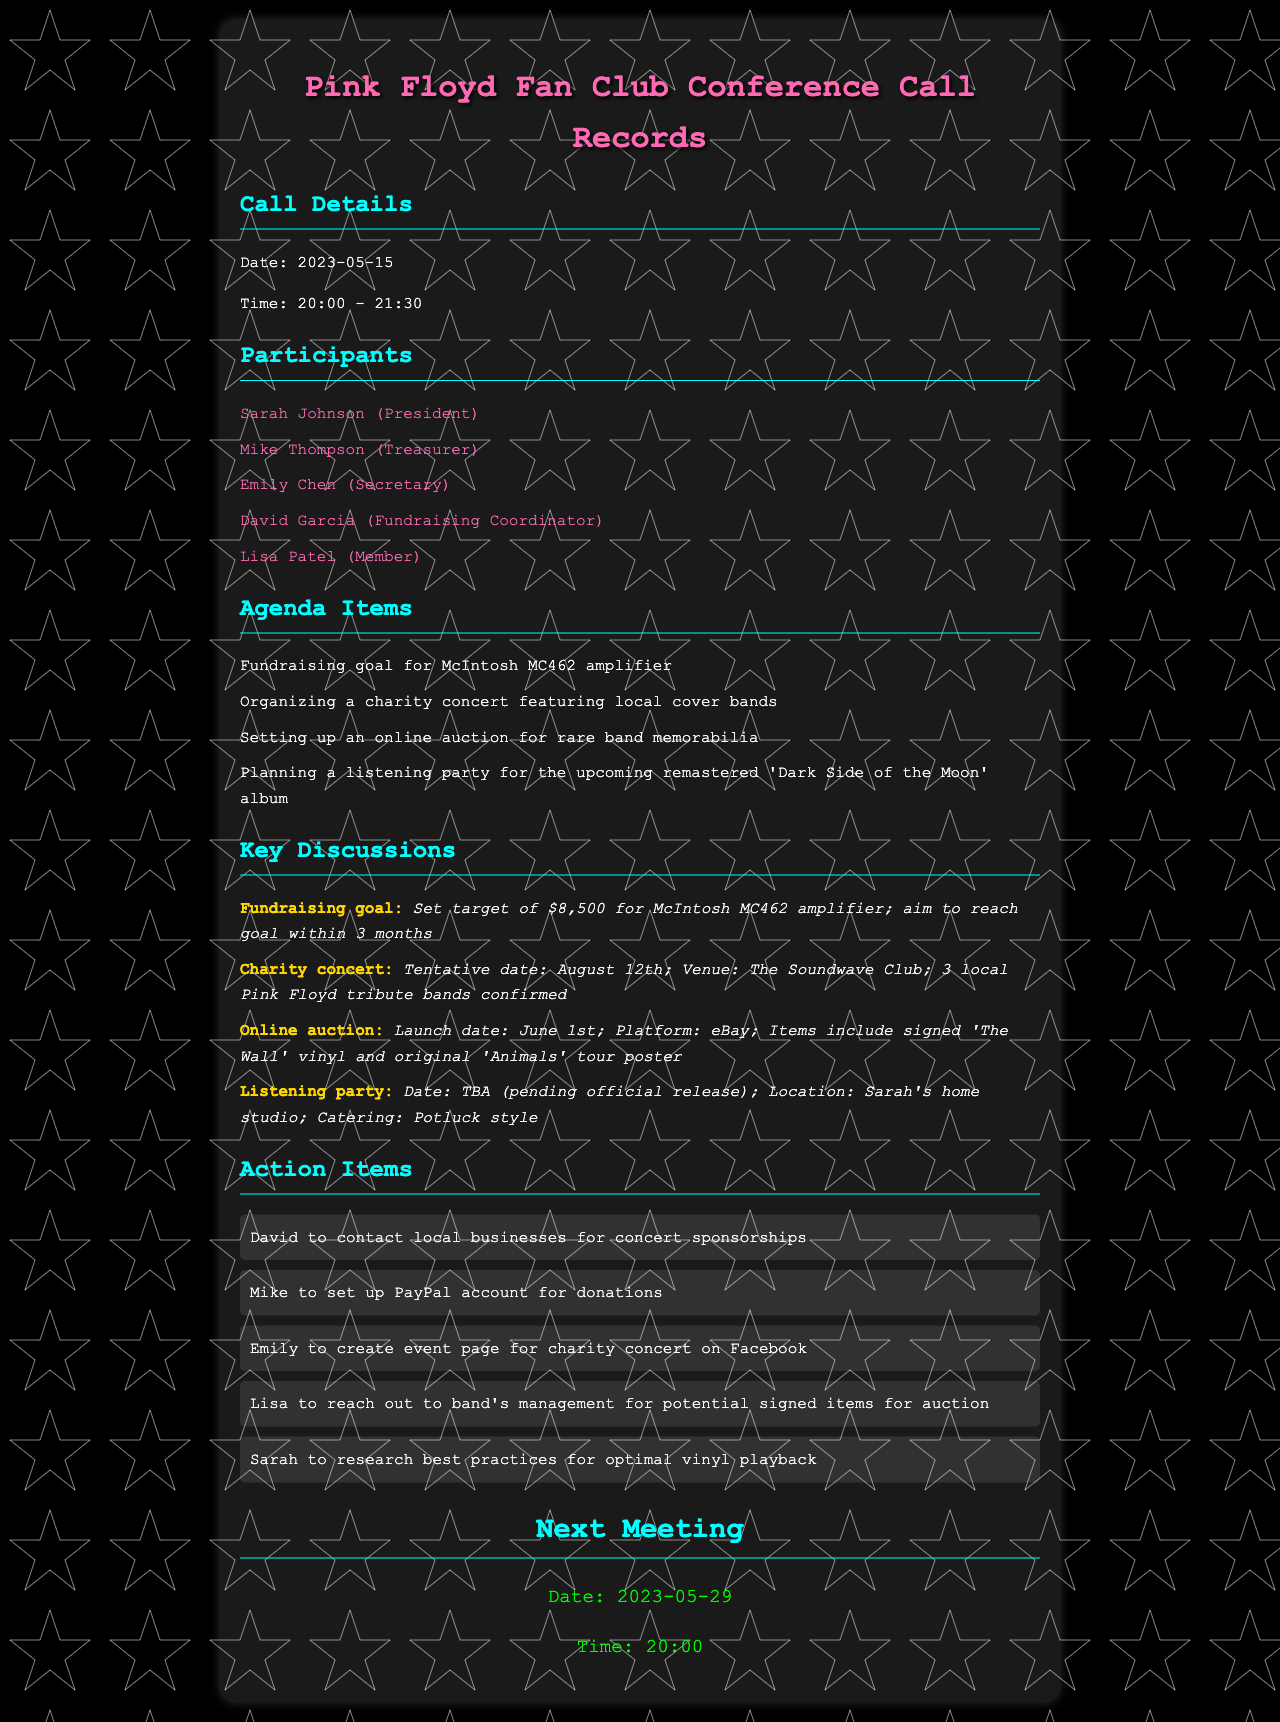What is the date of the conference call? The date of the conference call is explicitly mentioned in the call details section.
Answer: 2023-05-15 Who is the Treasurer of the fan club? The participants section lists all the members along with their roles, identifying Mike Thompson as the Treasurer.
Answer: Mike Thompson What is the fundraising goal amount for the amplifier? The key discussions section specifies the target fundraising amount mentioned in the discussion about the McIntosh MC462 amplifier.
Answer: $8,500 When is the tentative date for the charity concert? The key discussions section includes the planned date for the charity concert, providing specific details.
Answer: August 12th What platform will the online auction be held on? The key discussions outline the auction details, including the platform, which is noted for organizing the event.
Answer: eBay How many local tribute bands are confirmed for the charity concert? The key discussions indicate the number of tribute bands confirmed to participate in the charity concert.
Answer: 3 What date is the next meeting scheduled for? The next meeting section explicitly states the date for the follow-up meeting.
Answer: 2023-05-29 Who is responsible for contacting local businesses for concert sponsorships? The action items detail the responsibilities assigned to participants, indicating that this task is assigned to David.
Answer: David What type of catering is planned for the listening party? The details about the catering for the listening party can be found in the key discussions section.
Answer: Potluck style 